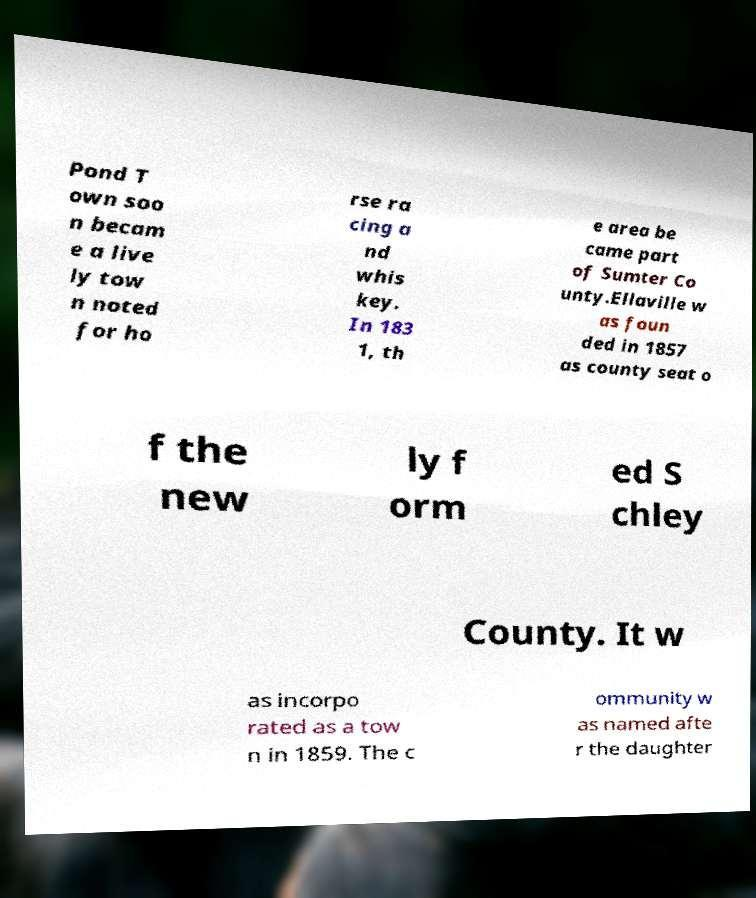Please identify and transcribe the text found in this image. Pond T own soo n becam e a live ly tow n noted for ho rse ra cing a nd whis key. In 183 1, th e area be came part of Sumter Co unty.Ellaville w as foun ded in 1857 as county seat o f the new ly f orm ed S chley County. It w as incorpo rated as a tow n in 1859. The c ommunity w as named afte r the daughter 